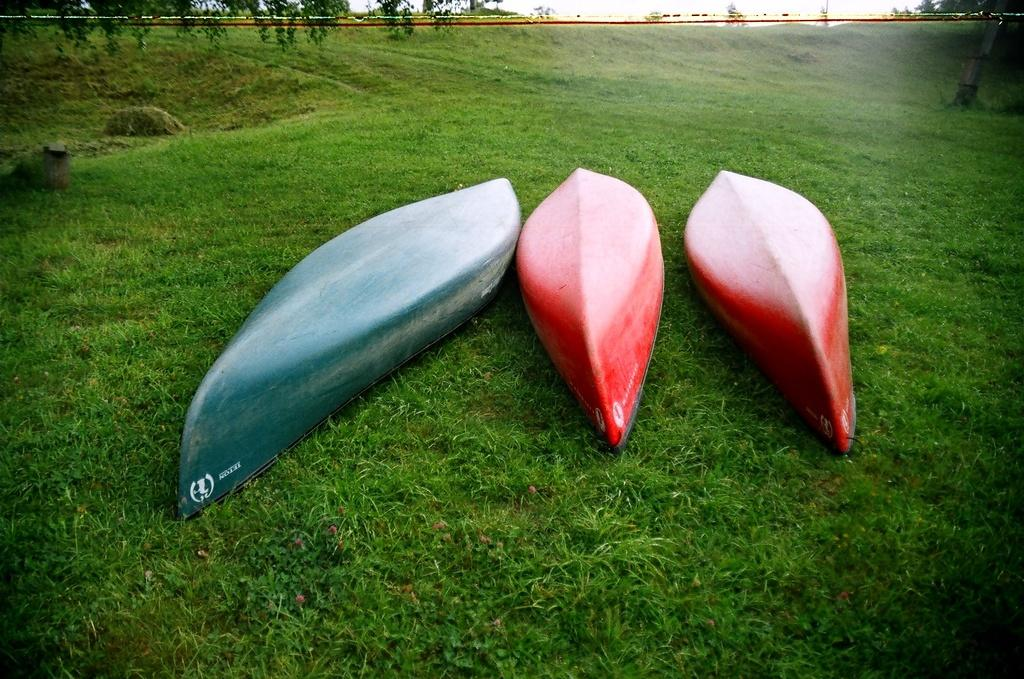How many boats can be seen in the image? There are three boats in the image. What is visible at the bottom of the image? There is grass visible at the bottom of the image. What type of railway can be seen in the image? There is no railway present in the image. What is the purpose of the shake in the image? There is no shake present in the image. 